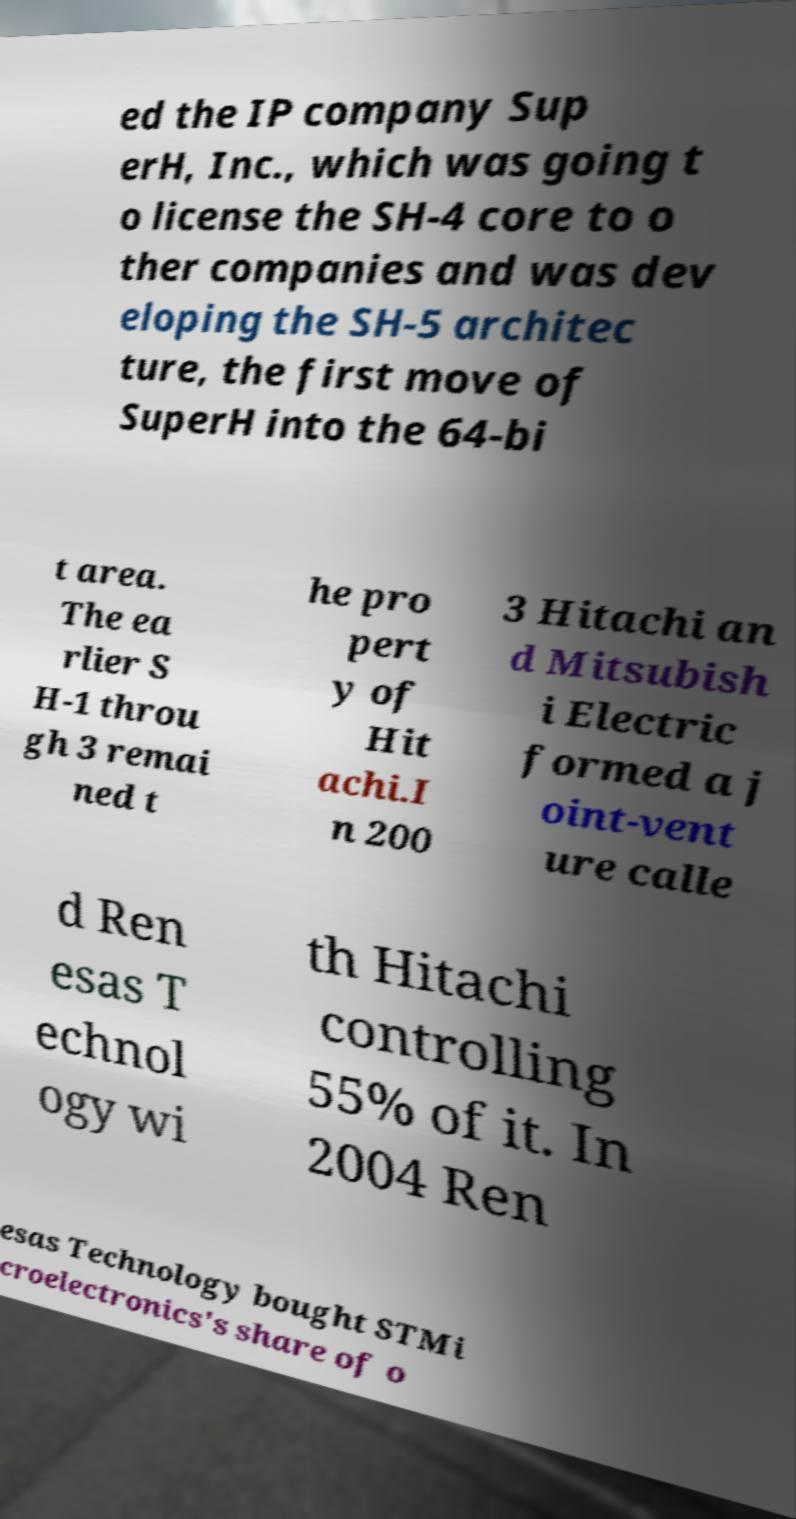Please identify and transcribe the text found in this image. ed the IP company Sup erH, Inc., which was going t o license the SH-4 core to o ther companies and was dev eloping the SH-5 architec ture, the first move of SuperH into the 64-bi t area. The ea rlier S H-1 throu gh 3 remai ned t he pro pert y of Hit achi.I n 200 3 Hitachi an d Mitsubish i Electric formed a j oint-vent ure calle d Ren esas T echnol ogy wi th Hitachi controlling 55% of it. In 2004 Ren esas Technology bought STMi croelectronics's share of o 